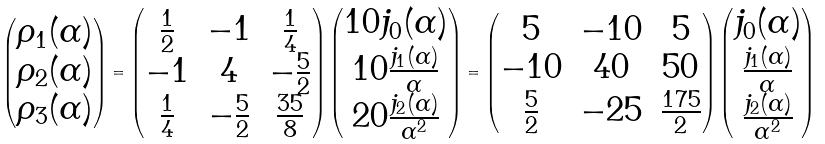<formula> <loc_0><loc_0><loc_500><loc_500>\begin{pmatrix} \rho _ { 1 } ( \alpha ) \\ \rho _ { 2 } ( \alpha ) \\ \rho _ { 3 } ( \alpha ) \end{pmatrix} = \begin{pmatrix} \frac { 1 } { 2 } & - 1 & \frac { 1 } { 4 } \\ - 1 & 4 & - \frac { 5 } { 2 } \\ \frac { 1 } { 4 } & - \frac { 5 } { 2 } & \frac { 3 5 } { 8 } \end{pmatrix} \begin{pmatrix} 1 0 j _ { 0 } ( \alpha ) \\ 1 0 \frac { j _ { 1 } ( \alpha ) } { \alpha } \\ 2 0 \frac { j _ { 2 } ( \alpha ) } { \alpha ^ { 2 } } \end{pmatrix} = \begin{pmatrix} 5 & - 1 0 & 5 \\ - 1 0 & 4 0 & 5 0 \\ \frac { 5 } { 2 } & - 2 5 & \frac { 1 7 5 } { 2 } \end{pmatrix} \begin{pmatrix} j _ { 0 } ( \alpha ) \\ \frac { j _ { 1 } ( \alpha ) } { \alpha } \\ \frac { j _ { 2 } ( \alpha ) } { \alpha ^ { 2 } } \end{pmatrix}</formula> 